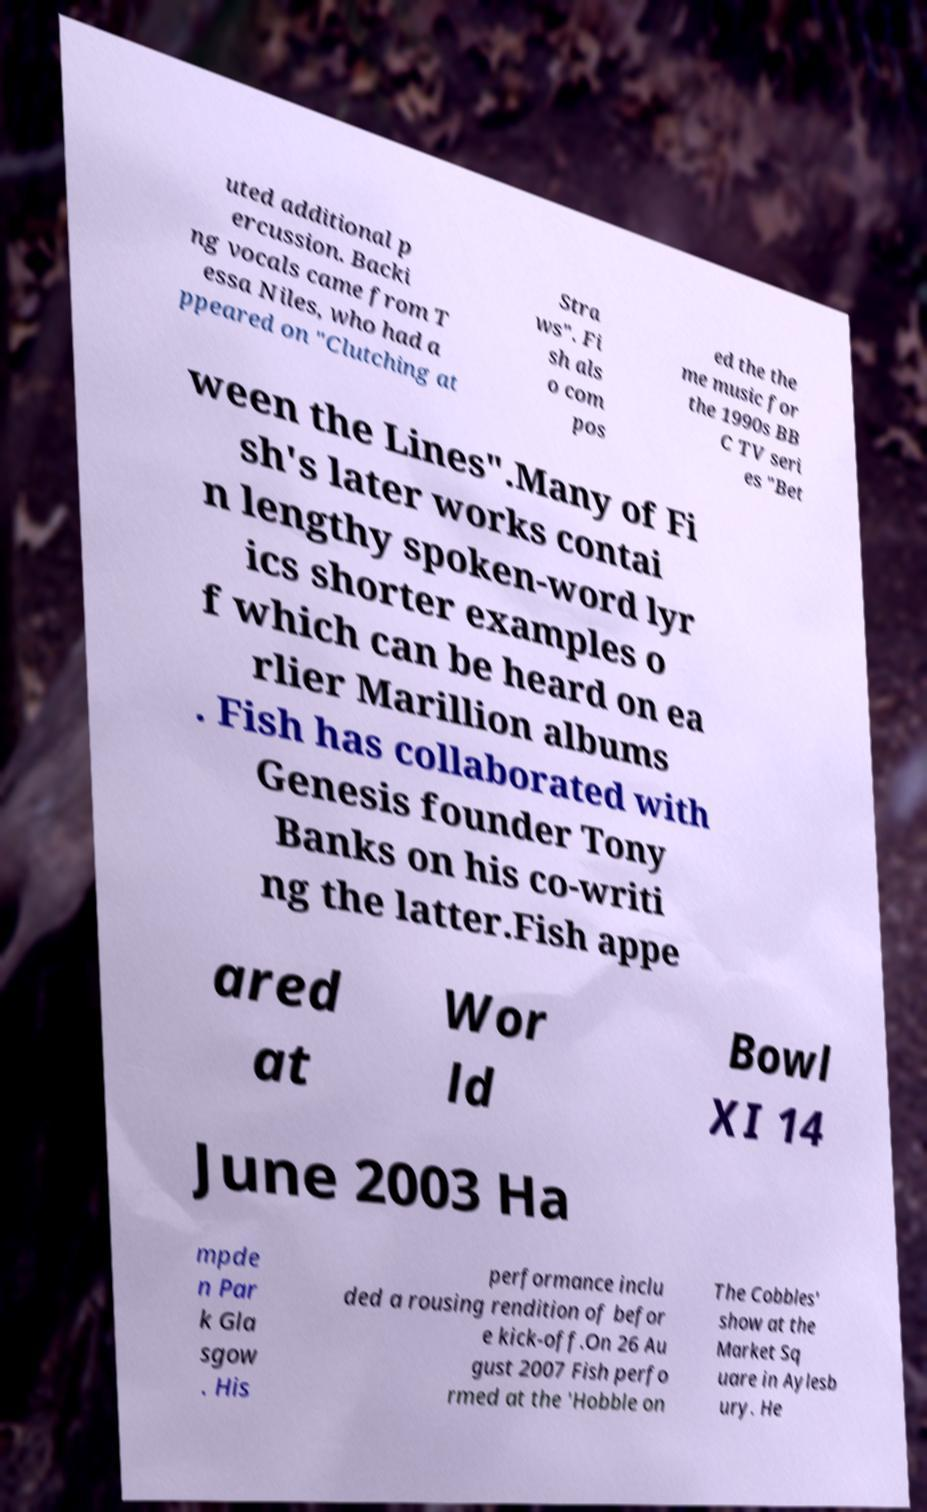There's text embedded in this image that I need extracted. Can you transcribe it verbatim? uted additional p ercussion. Backi ng vocals came from T essa Niles, who had a ppeared on "Clutching at Stra ws". Fi sh als o com pos ed the the me music for the 1990s BB C TV seri es "Bet ween the Lines".Many of Fi sh's later works contai n lengthy spoken-word lyr ics shorter examples o f which can be heard on ea rlier Marillion albums . Fish has collaborated with Genesis founder Tony Banks on his co-writi ng the latter.Fish appe ared at Wor ld Bowl XI 14 June 2003 Ha mpde n Par k Gla sgow . His performance inclu ded a rousing rendition of befor e kick-off.On 26 Au gust 2007 Fish perfo rmed at the 'Hobble on The Cobbles' show at the Market Sq uare in Aylesb ury. He 